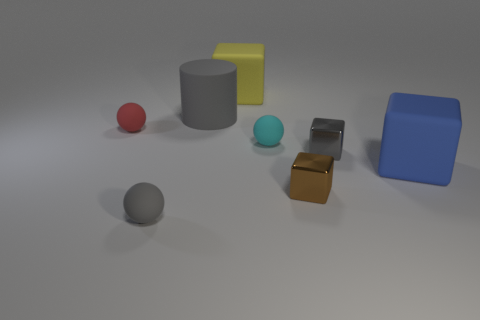Subtract all large yellow cubes. How many cubes are left? 3 Add 1 small cyan objects. How many objects exist? 9 Subtract all yellow blocks. How many blocks are left? 3 Subtract all cylinders. How many objects are left? 7 Subtract 2 spheres. How many spheres are left? 1 Subtract all green cylinders. Subtract all blue cubes. How many cylinders are left? 1 Subtract all gray balls. How many brown blocks are left? 1 Subtract all cylinders. Subtract all small gray matte objects. How many objects are left? 6 Add 2 small gray matte objects. How many small gray matte objects are left? 3 Add 4 brown shiny blocks. How many brown shiny blocks exist? 5 